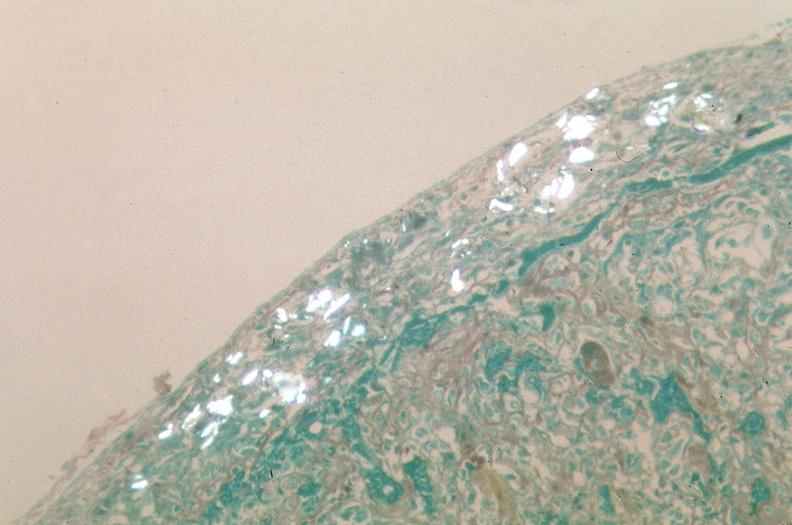s pancreas present?
Answer the question using a single word or phrase. No 